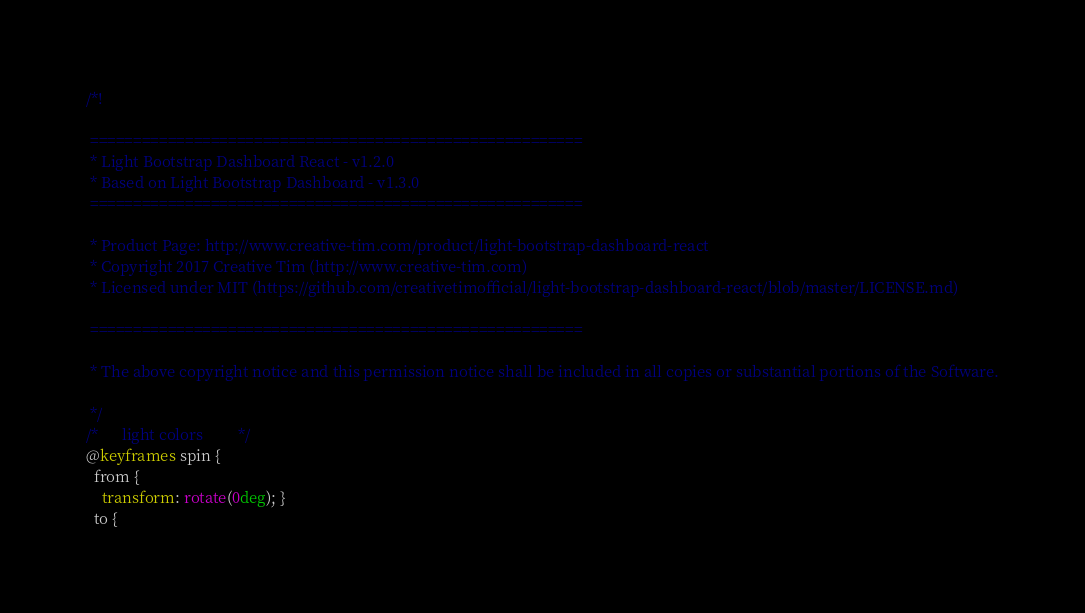<code> <loc_0><loc_0><loc_500><loc_500><_CSS_>/*!

 =========================================================
 * Light Bootstrap Dashboard React - v1.2.0
 * Based on Light Bootstrap Dashboard - v1.3.0
 =========================================================

 * Product Page: http://www.creative-tim.com/product/light-bootstrap-dashboard-react
 * Copyright 2017 Creative Tim (http://www.creative-tim.com)
 * Licensed under MIT (https://github.com/creativetimofficial/light-bootstrap-dashboard-react/blob/master/LICENSE.md)

 =========================================================

 * The above copyright notice and this permission notice shall be included in all copies or substantial portions of the Software.

 */
/*      light colors         */
@keyframes spin {
  from {
    transform: rotate(0deg); }
  to {</code> 